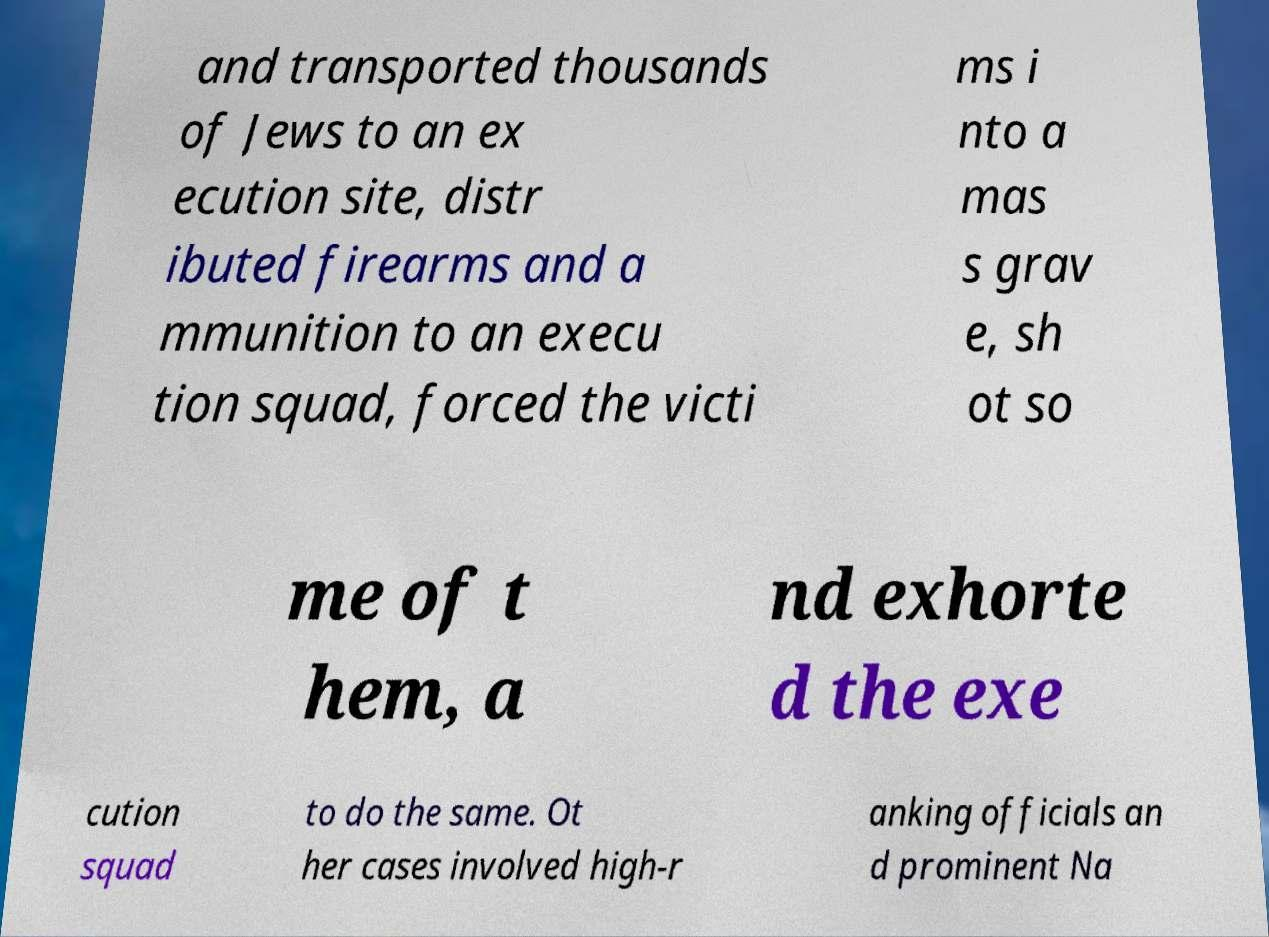There's text embedded in this image that I need extracted. Can you transcribe it verbatim? and transported thousands of Jews to an ex ecution site, distr ibuted firearms and a mmunition to an execu tion squad, forced the victi ms i nto a mas s grav e, sh ot so me of t hem, a nd exhorte d the exe cution squad to do the same. Ot her cases involved high-r anking officials an d prominent Na 